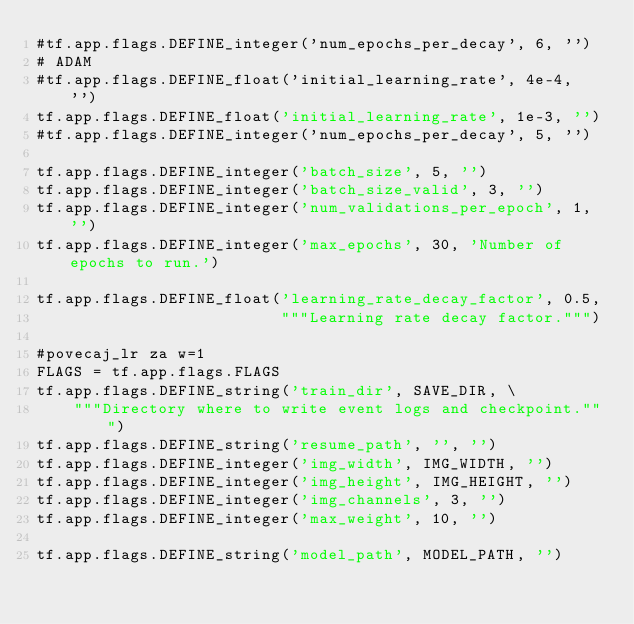Convert code to text. <code><loc_0><loc_0><loc_500><loc_500><_Python_>#tf.app.flags.DEFINE_integer('num_epochs_per_decay', 6, '')
# ADAM
#tf.app.flags.DEFINE_float('initial_learning_rate', 4e-4, '')
tf.app.flags.DEFINE_float('initial_learning_rate', 1e-3, '')
#tf.app.flags.DEFINE_integer('num_epochs_per_decay', 5, '')

tf.app.flags.DEFINE_integer('batch_size', 5, '')
tf.app.flags.DEFINE_integer('batch_size_valid', 3, '')
tf.app.flags.DEFINE_integer('num_validations_per_epoch', 1, '')
tf.app.flags.DEFINE_integer('max_epochs', 30, 'Number of epochs to run.')

tf.app.flags.DEFINE_float('learning_rate_decay_factor', 0.5,
                          """Learning rate decay factor.""")

#povecaj_lr za w=1
FLAGS = tf.app.flags.FLAGS
tf.app.flags.DEFINE_string('train_dir', SAVE_DIR, \
    """Directory where to write event logs and checkpoint.""")
tf.app.flags.DEFINE_string('resume_path', '', '')
tf.app.flags.DEFINE_integer('img_width', IMG_WIDTH, '')
tf.app.flags.DEFINE_integer('img_height', IMG_HEIGHT, '')
tf.app.flags.DEFINE_integer('img_channels', 3, '')
tf.app.flags.DEFINE_integer('max_weight', 10, '')

tf.app.flags.DEFINE_string('model_path', MODEL_PATH, '')</code> 